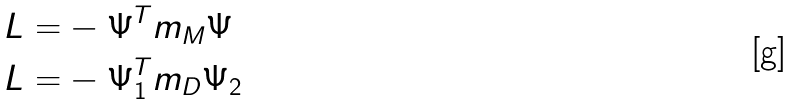Convert formula to latex. <formula><loc_0><loc_0><loc_500><loc_500>L = & - \Psi ^ { T } m _ { M } \Psi \\ L = & - \Psi _ { 1 } ^ { T } m _ { D } \Psi _ { 2 }</formula> 